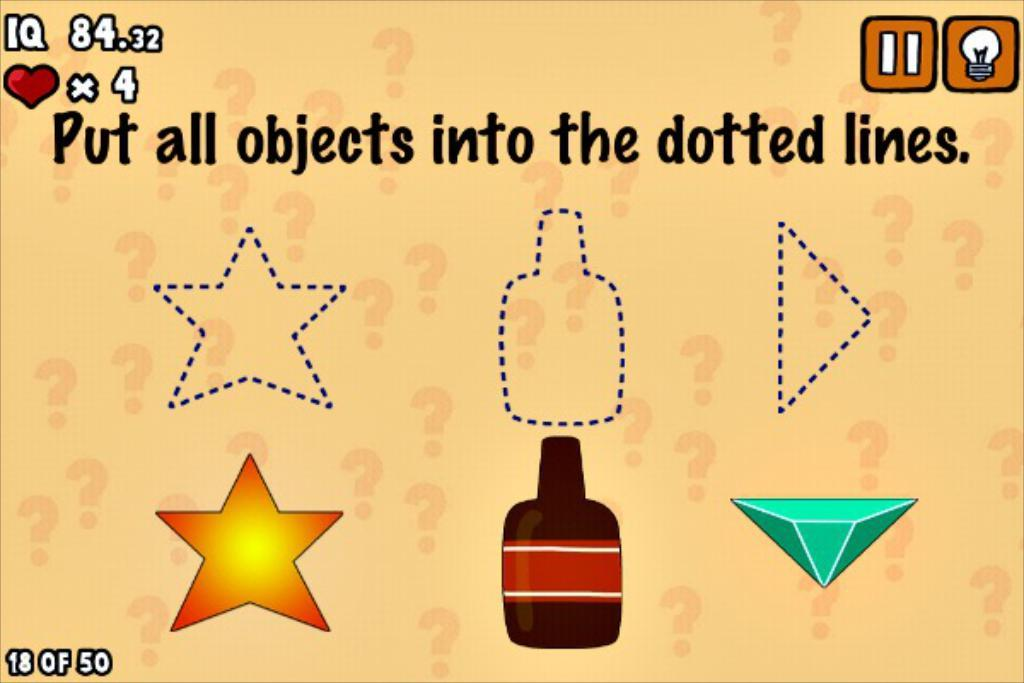<image>
Write a terse but informative summary of the picture. Put all objects into the dotted line written with three dotted line shapes. 